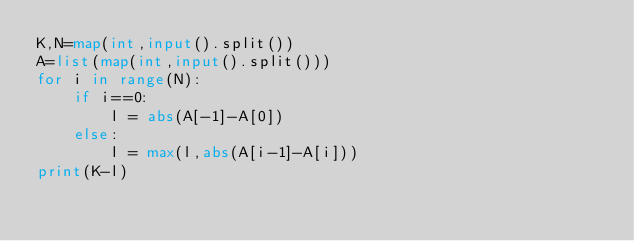Convert code to text. <code><loc_0><loc_0><loc_500><loc_500><_Python_>K,N=map(int,input().split())
A=list(map(int,input().split()))
for i in range(N):
    if i==0:
        l = abs(A[-1]-A[0])
    else:
        l = max(l,abs(A[i-1]-A[i]))
print(K-l)</code> 